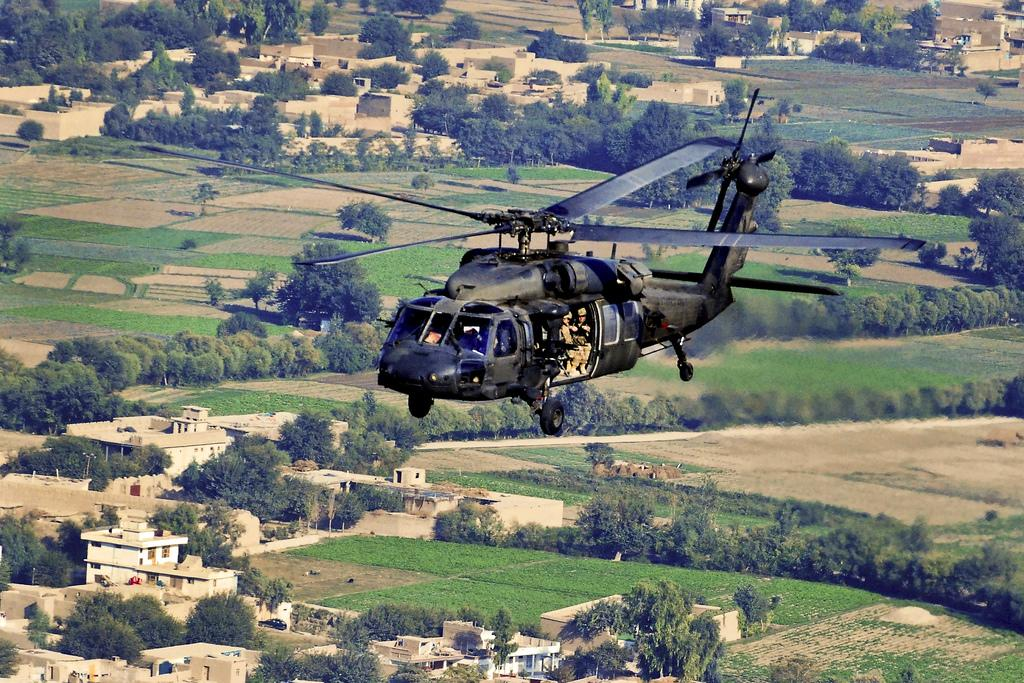What is flying in the air in the image? There is a helicopter flying in the air in the image. What can be seen on the ground in the image? There are trees on the ground in the image. What type of structures are visible in the image? There are homes visible in the image. What is the purpose of the collar in the image? There is no collar present in the image. 